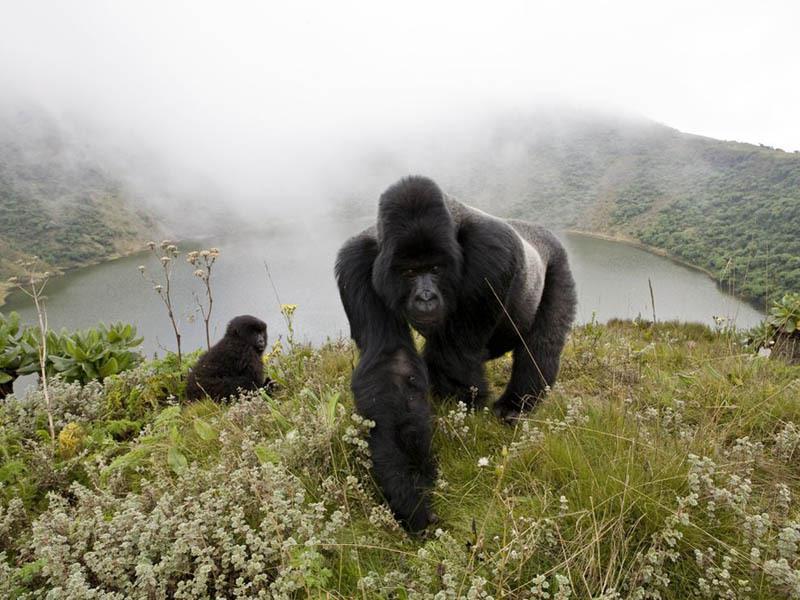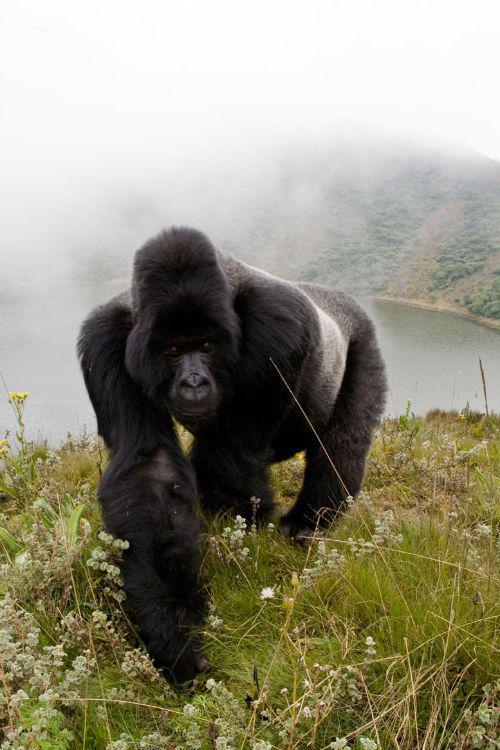The first image is the image on the left, the second image is the image on the right. Analyze the images presented: Is the assertion "there is a long silverback gorilla on a hilltop overlooking a pool of water with fog" valid? Answer yes or no. Yes. 